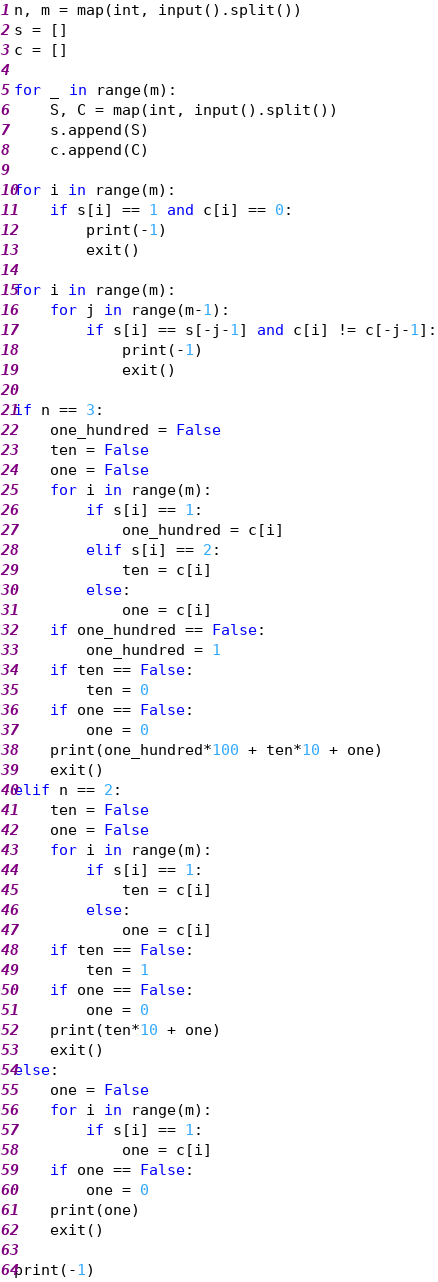Convert code to text. <code><loc_0><loc_0><loc_500><loc_500><_Python_>n, m = map(int, input().split())
s = []
c = []

for _ in range(m):
    S, C = map(int, input().split())
    s.append(S)
    c.append(C)

for i in range(m):
    if s[i] == 1 and c[i] == 0:
        print(-1)
        exit()

for i in range(m):
    for j in range(m-1):
        if s[i] == s[-j-1] and c[i] != c[-j-1]:
            print(-1)
            exit()

if n == 3:
    one_hundred = False
    ten = False
    one = False
    for i in range(m):
        if s[i] == 1:
            one_hundred = c[i]
        elif s[i] == 2:
            ten = c[i]
        else:
            one = c[i]
    if one_hundred == False:
        one_hundred = 1
    if ten == False:
        ten = 0
    if one == False:
        one = 0
    print(one_hundred*100 + ten*10 + one)
    exit()
elif n == 2:
    ten = False
    one = False
    for i in range(m):
        if s[i] == 1:
            ten = c[i]
        else:
            one = c[i] 
    if ten == False:
        ten = 1
    if one == False:
        one = 0
    print(ten*10 + one)
    exit()
else:
    one = False
    for i in range(m):
        if s[i] == 1:
            one = c[i]
    if one == False:
        one = 0
    print(one)
    exit()

print(-1)</code> 